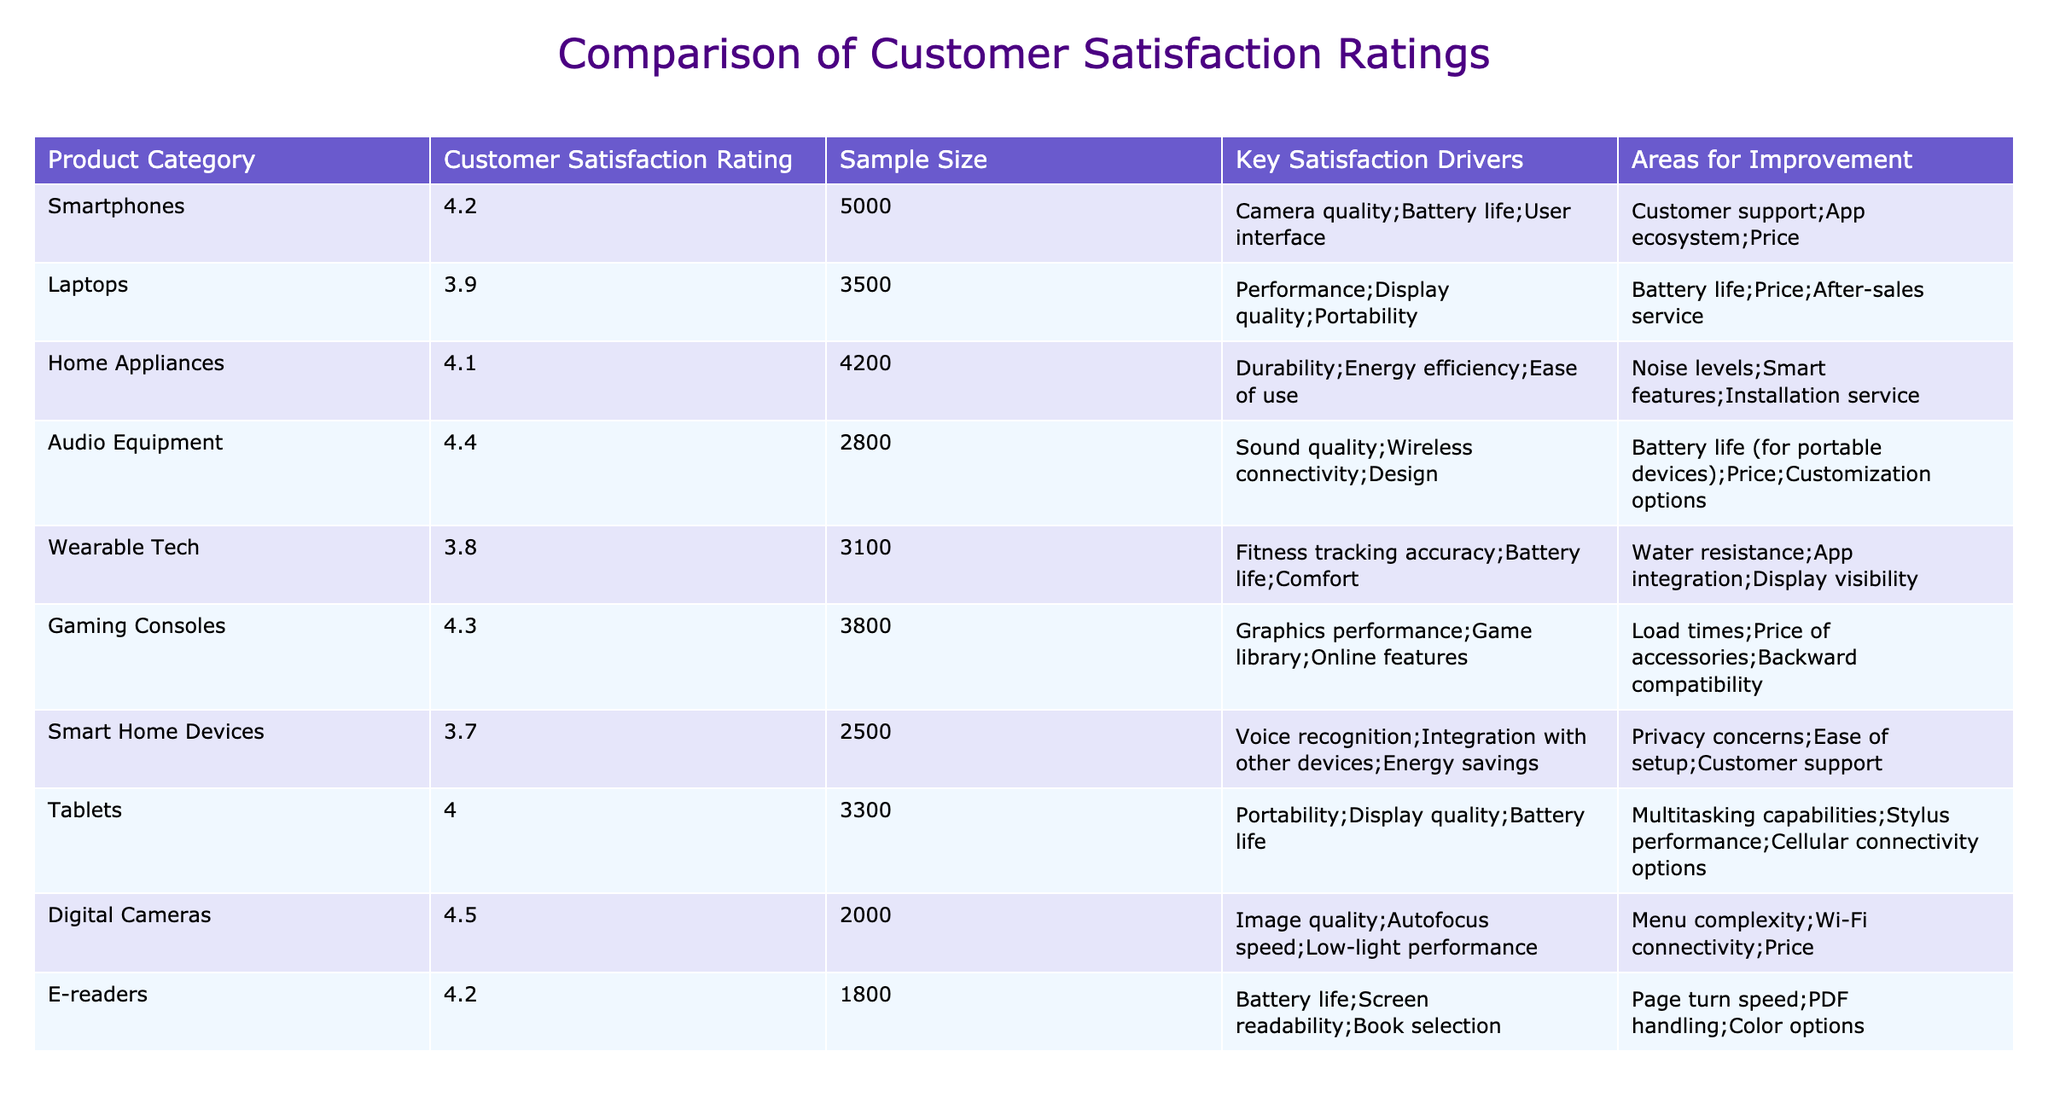What is the customer satisfaction rating for Digital Cameras? The table lists the customer satisfaction rating for Digital Cameras as 4.5.
Answer: 4.5 Which product category has the lowest customer satisfaction rating? Looking through the ratings in the table, Smart Home Devices has the lowest rating at 3.7.
Answer: Smart Home Devices How many products have a customer satisfaction rating above 4.0? Checking the ratings, the product categories with ratings above 4.0 are Smartphones (4.2), Home Appliances (4.1), Audio Equipment (4.4), Gaming Consoles (4.3), Digital Cameras (4.5), and E-readers (4.2), making a total of 6.
Answer: 6 What is the average customer satisfaction rating for products that are portable? The portable products are Smartphones (4.2), Laptops (3.9), Tablets (4.0), and Wearable Tech (3.8). Their ratings sum to 15.9 (4.2 + 3.9 + 4.0 + 3.8) divided by 4 gives an average of 3.975.
Answer: 3.975 Do more than four product categories have "battery life" as a key satisfaction driver? Reviewing the table, the product categories with "battery life" listed as a satisfaction driver are Smartphones, Laptops, Audio Equipment, Wearable Tech, and Tablets, which totals to 5 categories.
Answer: Yes Which product category has the highest satisfaction rating and what is its key satisfaction driver? The highest satisfaction rating is 4.5 for Digital Cameras, and its key satisfaction drivers include image quality, autofocus speed, and low-light performance.
Answer: Digital Cameras, Image Quality What is the satisfaction rating difference between Audio Equipment and Wearable Tech? Audio Equipment has a rating of 4.4 while Wearable Tech has a rating of 3.8. The difference is calculated as 4.4 - 3.8, which equals 0.6.
Answer: 0.6 In which product category is "price" noted as an area for improvement? Noting the table entries, “price” is listed as an area for improvement in Smartphones, Laptops, Audio Equipment, Gaming Consoles, and Smart Home Devices, corresponding to five categories.
Answer: 5 categories Which product category has the highest sample size and what is that size? Examining the sample sizes, Smartphones has the highest sample size recorded at 5000.
Answer: 5000 